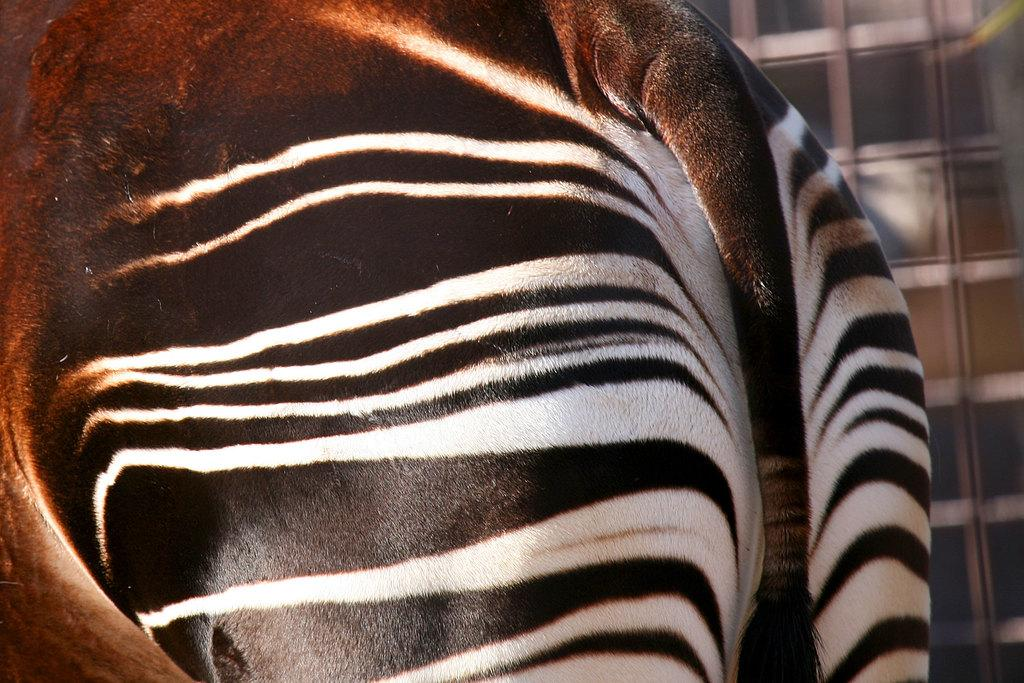What type of animal is in the image? The specific type of animal cannot be determined from the provided facts. Can you describe the background of the image? The background of the image is blurry. What type of account does the animal have in the image? There is no information about an account in the image, as it features an animal and a blurry background. Is there any agreement between the animal and the background in the image? There is no indication of an agreement between the animal and the background in the image, as they are separate elements. 